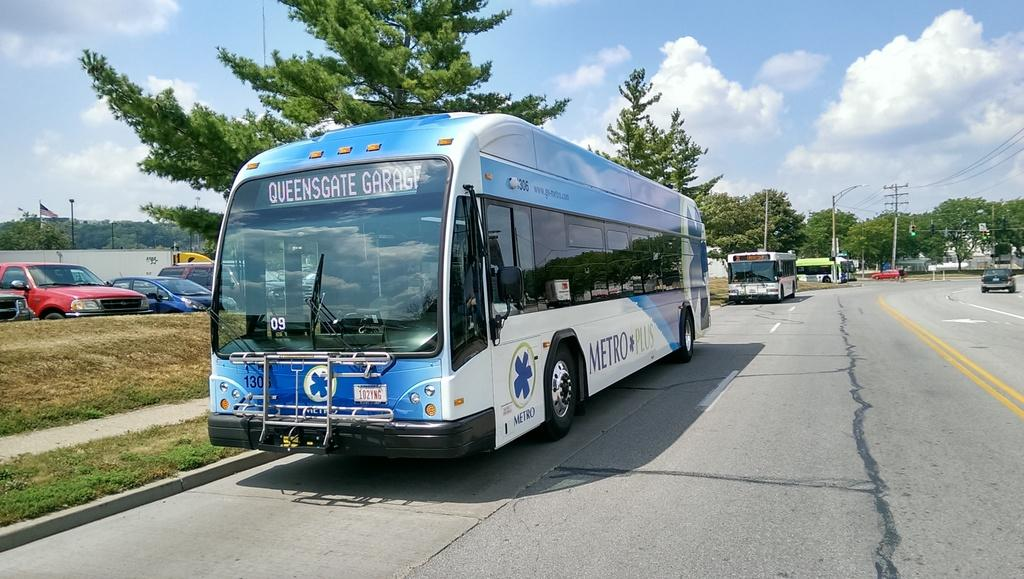Provide a one-sentence caption for the provided image. A bus with the text Metro Plus on the side is parked on a street next to a sidewalk. 